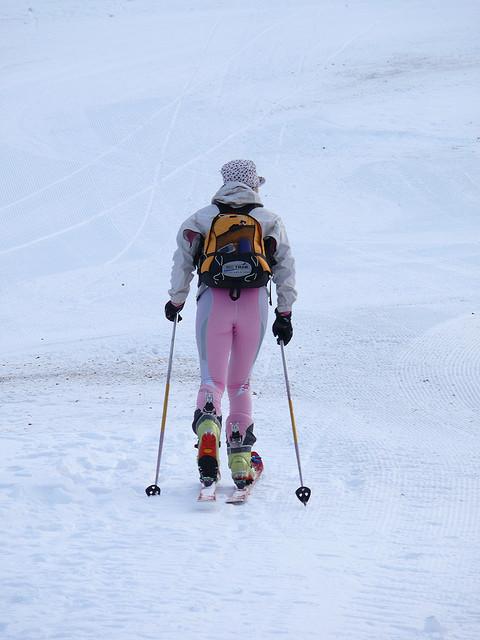What sport are they doing?
Concise answer only. Skiing. What color are here pants?
Concise answer only. Pink. How many people seen?
Give a very brief answer. 1. How old is the child?
Keep it brief. 16. 